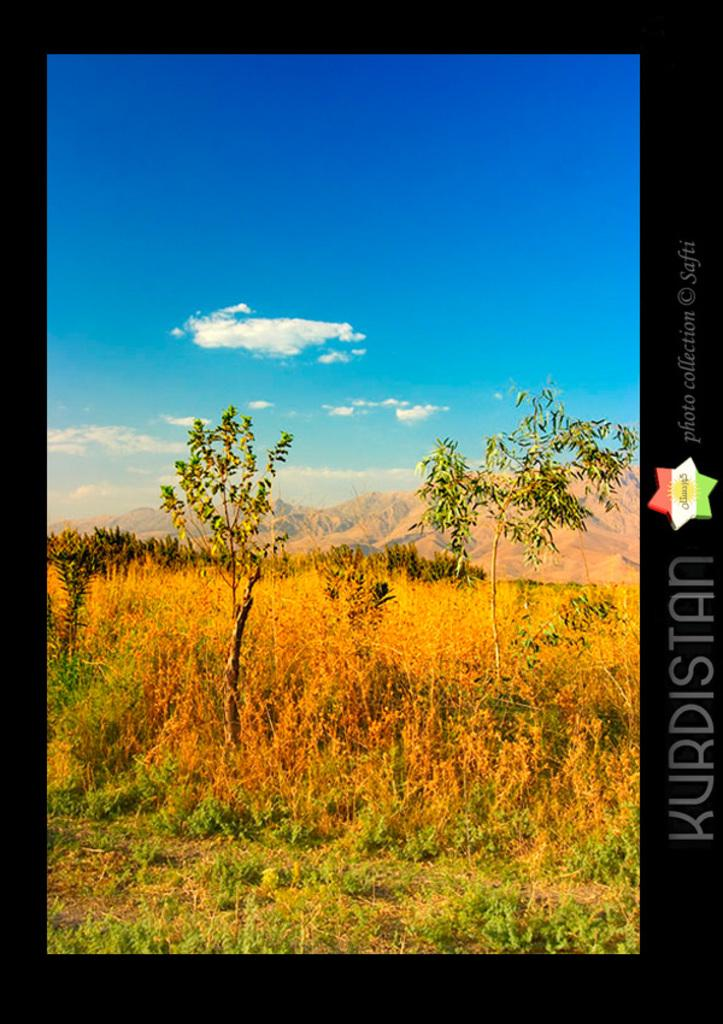What type of living organisms can be seen in the image? Plants can be seen in the image. What natural feature is visible in the background of the image? There are mountains in the background of the image. What type of lines or borders are present in the image? There are black boundaries in the image. What type of wire is holding up the nation in the image? There is no wire or nation present in the image. 